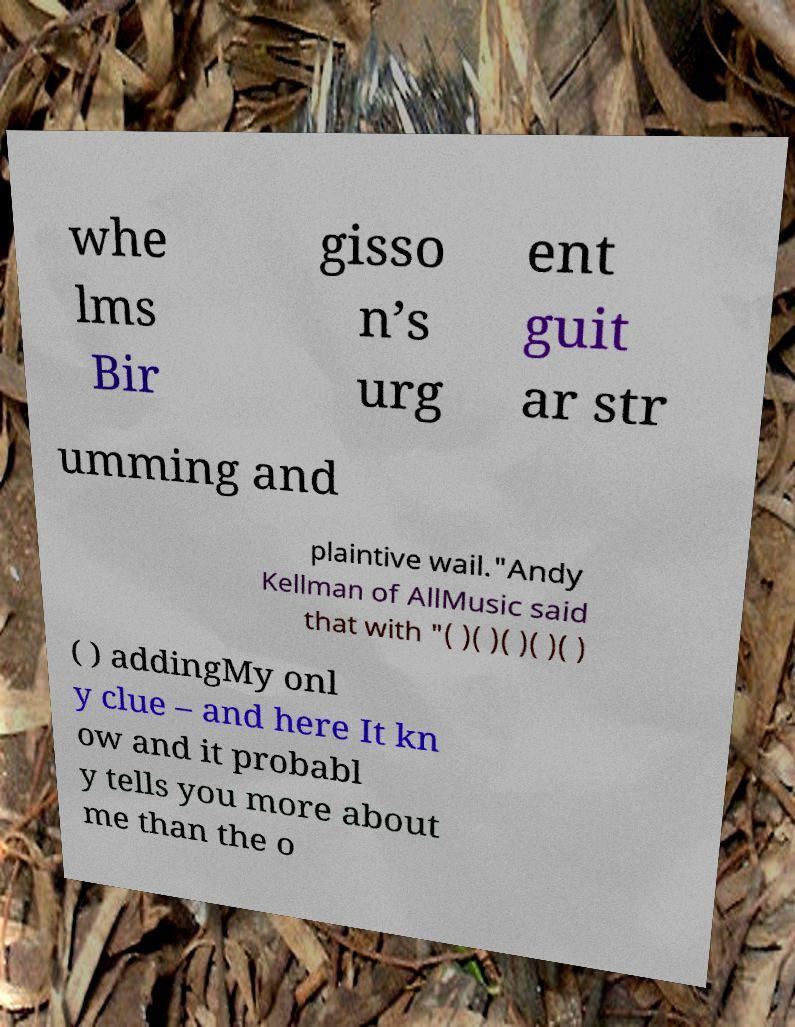There's text embedded in this image that I need extracted. Can you transcribe it verbatim? whe lms Bir gisso n’s urg ent guit ar str umming and plaintive wail."Andy Kellman of AllMusic said that with "( )( )( )( )( ) ( ) addingMy onl y clue – and here It kn ow and it probabl y tells you more about me than the o 